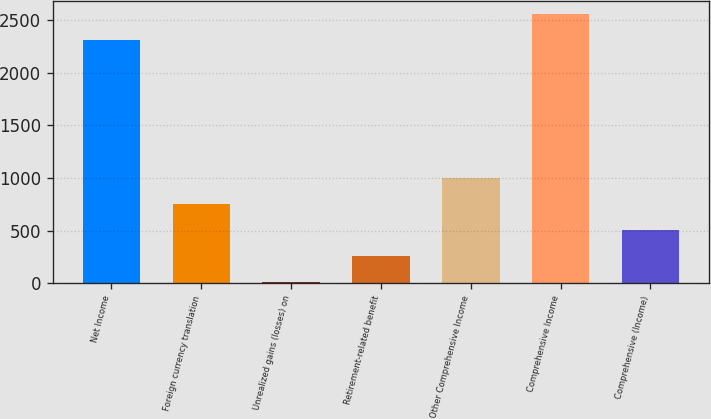<chart> <loc_0><loc_0><loc_500><loc_500><bar_chart><fcel>Net Income<fcel>Foreign currency translation<fcel>Unrealized gains (losses) on<fcel>Retirement-related benefit<fcel>Other Comprehensive Income<fcel>Comprehensive Income<fcel>Comprehensive (Income)<nl><fcel>2310<fcel>750.9<fcel>9<fcel>256.3<fcel>998.2<fcel>2557.3<fcel>503.6<nl></chart> 